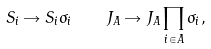Convert formula to latex. <formula><loc_0><loc_0><loc_500><loc_500>S _ { i } \rightarrow S _ { i } \sigma _ { i } \quad J _ { A } \rightarrow J _ { A } \prod _ { i \in A } \sigma _ { i } ,</formula> 